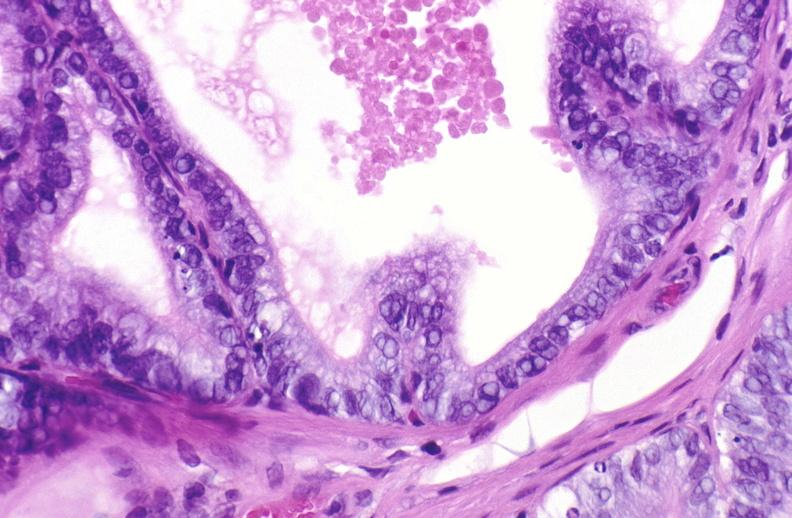does this image show apoptosis in prostate after orchiectomy?
Answer the question using a single word or phrase. Yes 